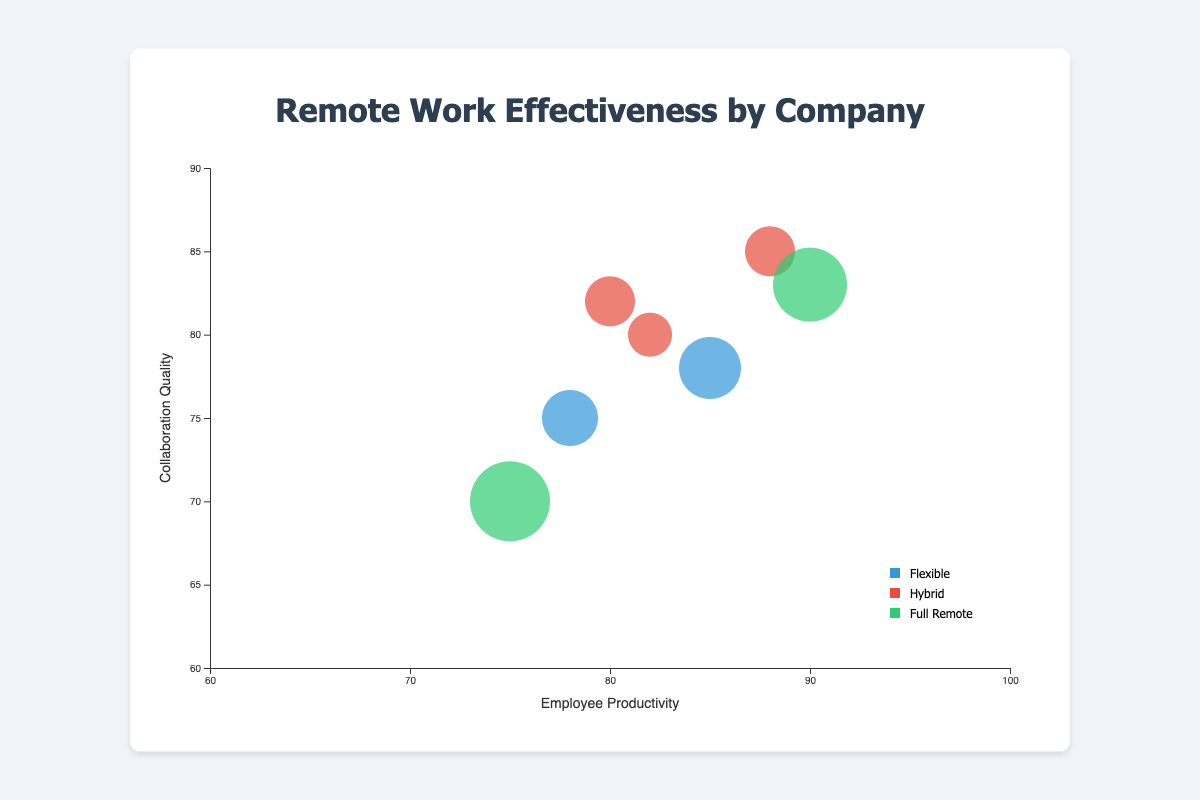What's the title of the chart? The title of the chart is displayed at the top and reads "Remote Work Effectiveness by Company".
Answer: Remote Work Effectiveness by Company What is the x-axis labeled? The x-axis is labeled "Employee Productivity" and this label is specifically placed horizontally underneath the x-axis.
Answer: Employee Productivity Which company has the highest Employee Productivity? By finding the circle positioned the furthest to the right along the x-axis, we see "Green Energy," which has an Employee Productivity of 90.
Answer: Green Energy Which remote work policy has the most number of companies? By counting the distinct colored circles visible in the legend, "Hybrid" appears the most frequently, represented by three data points.
Answer: Hybrid Which company has the lowest Collaboration Quality? By locating the circle positioned at the bottommost point on the y-axis, we see "Health Solutions," which has a Collaboration Quality of 70.
Answer: Health Solutions How many companies have an Employee Productivity higher than 80? Spotting all circles to the right of the 80-mark on the x-axis, we count four companies: Tech Innovators, EduMentors, Retail Giants, and Green Energy.
Answer: Four What is the median Collaboration Quality value? The Collaboration Quality values are 78, 82, 70, 75, 80, 85, and 83. Ordering these, we get 70, 75, 78, 80, 82, 83, 85. The median is the middle value, which is 80.
Answer: 80 Which company has the largest bubble size, indicating the highest Remote Work Percentage? Observing the largest circle, it belongs to "Health Solutions," indicating a Remote Work Percentage of 100%.
Answer: Health Solutions Comparing Tech Innovators and Finance Gurus, which one has higher Collaboration Quality? By locating both companies and comparing their positions on the y-axis, Tech Innovators has a Collaboration Quality of 78 while Finance Gurus has 75. Thus, Tech Innovators is higher.
Answer: Tech Innovators Which combination of department and company has hybrid remote work policies? By identifying circles colored for hybrid policies in the legend and cross-referencing with associated companies and departments: Global Consult (Consulting), Retail Giants (Operations), and EduMentors (Education).
Answer: Global Consult (Consulting), Retail Giants (Operations), EduMentors (Education) 